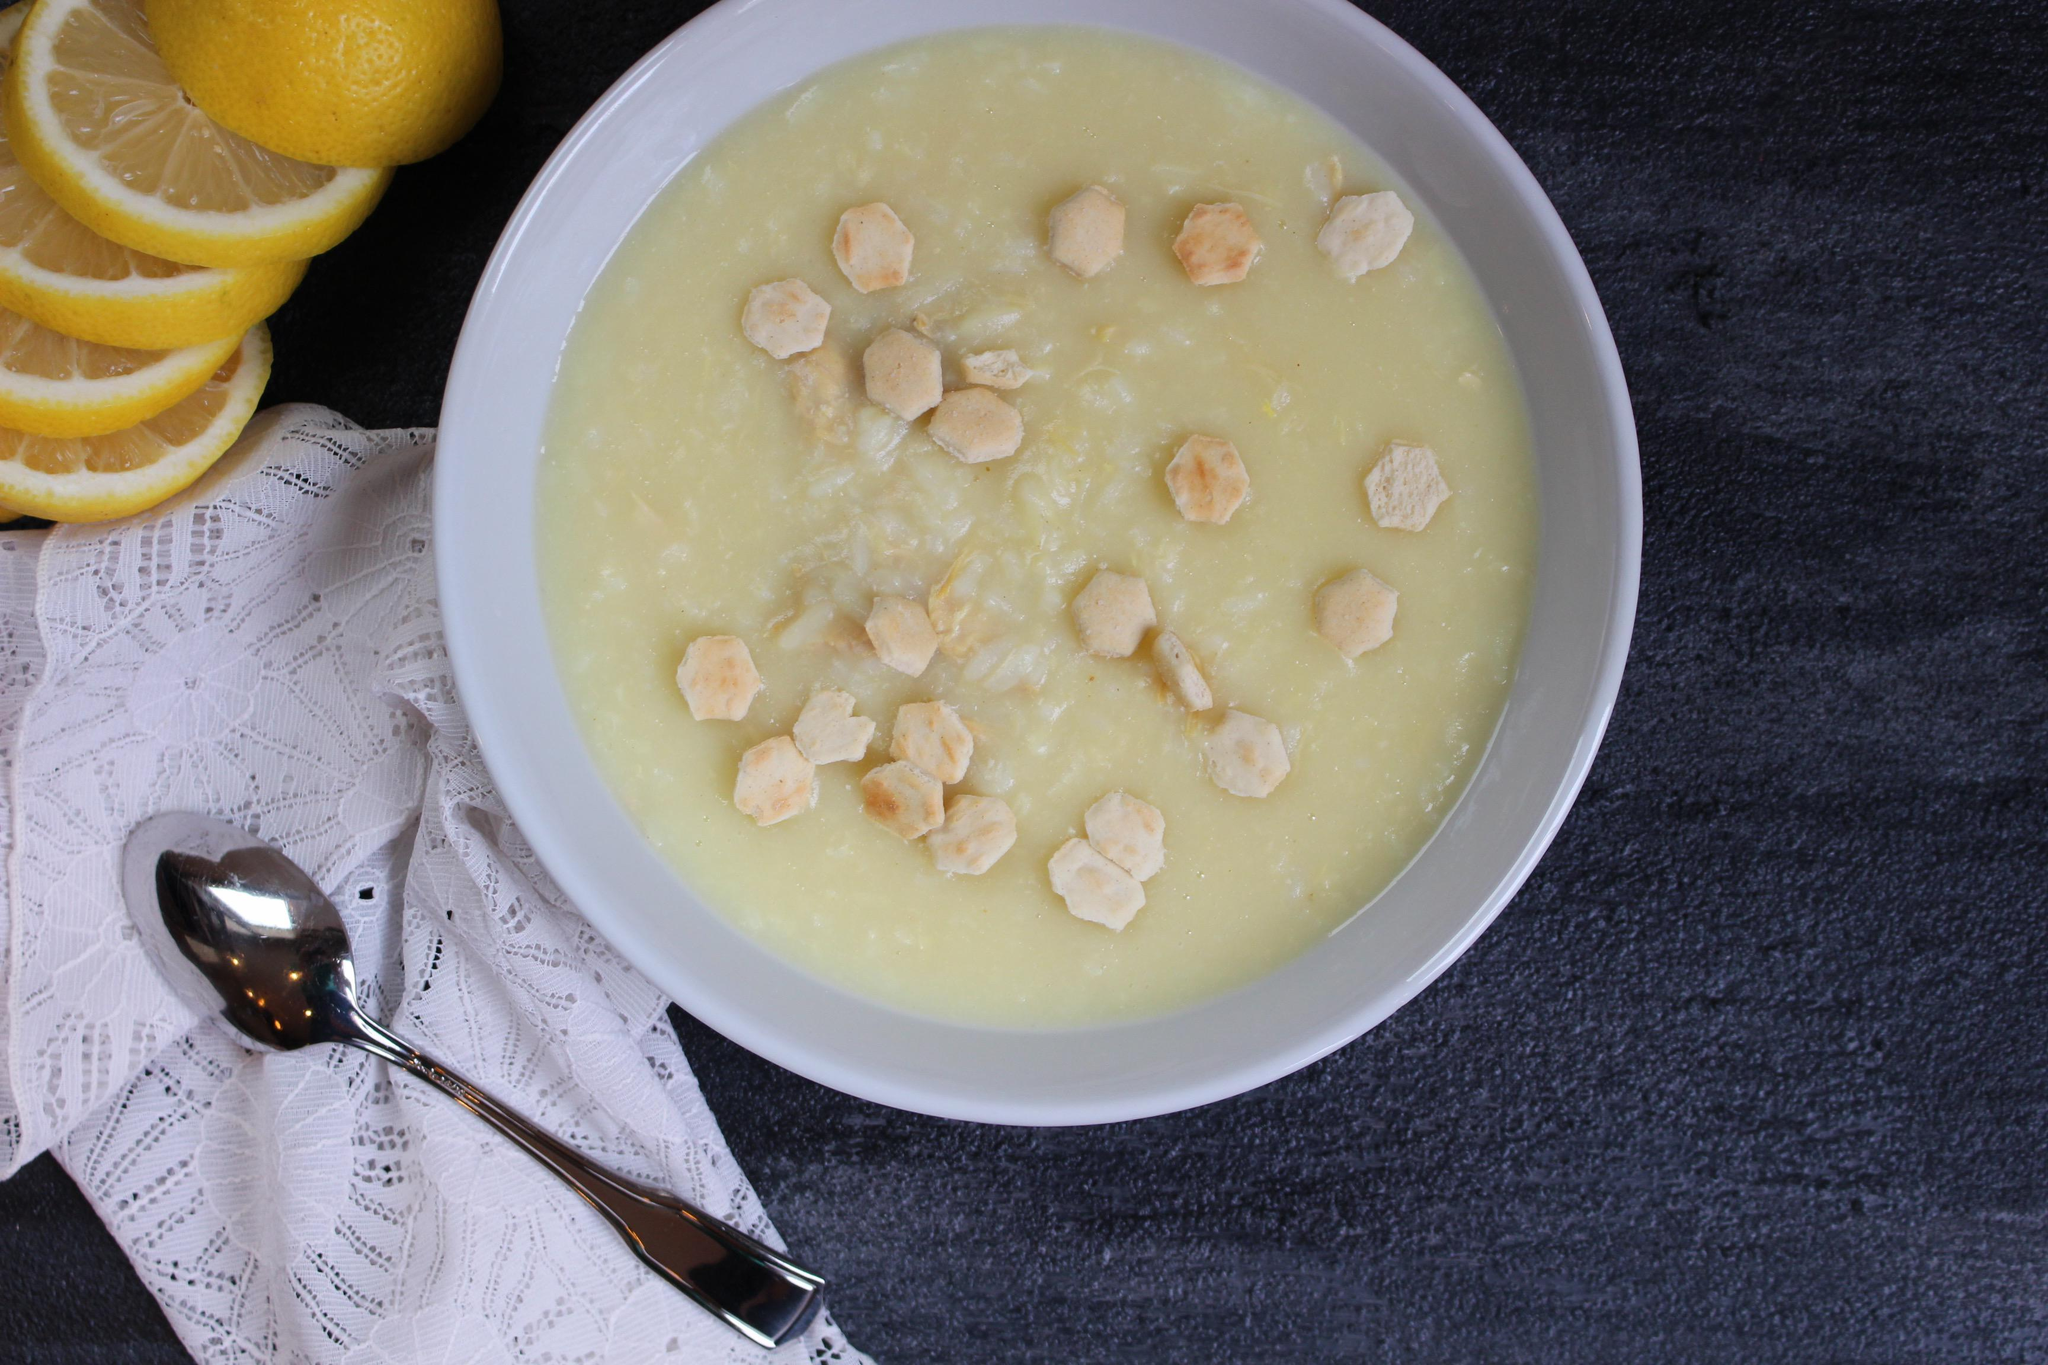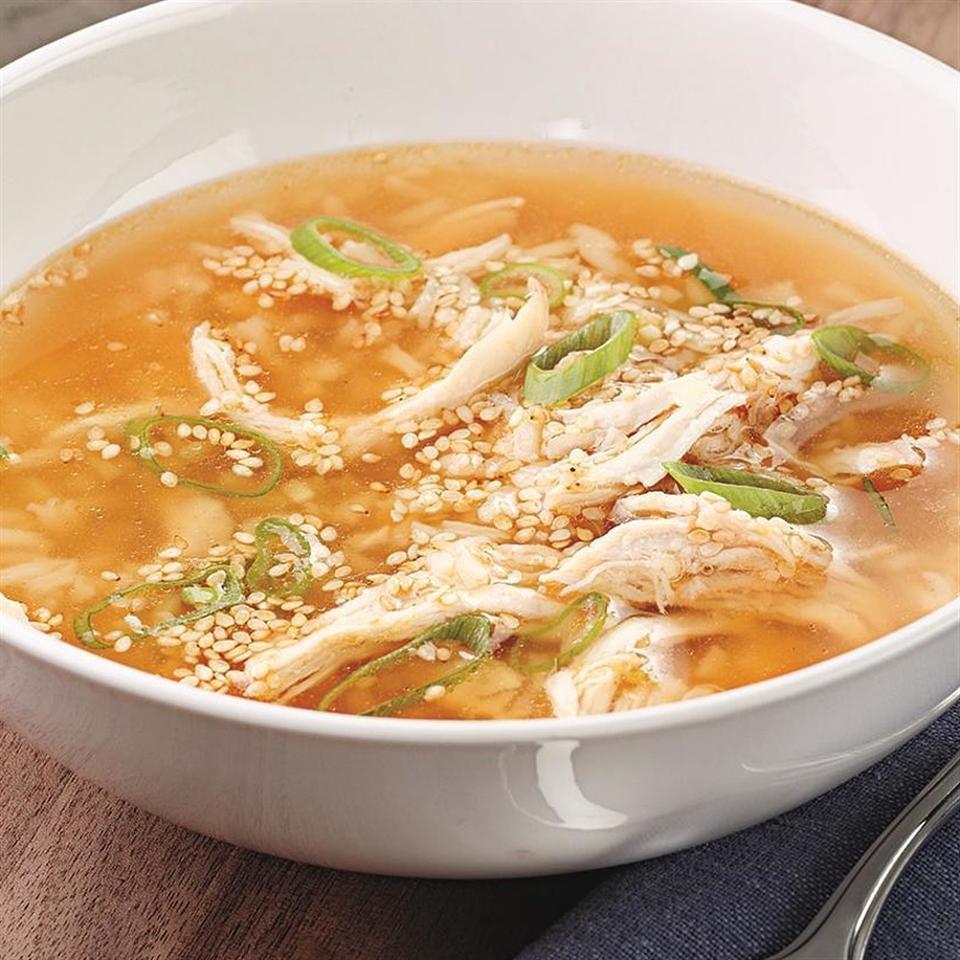The first image is the image on the left, the second image is the image on the right. Evaluate the accuracy of this statement regarding the images: "there is a spoon in the bowl of soup". Is it true? Answer yes or no. No. The first image is the image on the left, the second image is the image on the right. Analyze the images presented: Is the assertion "A spoon is in a white bowl of chicken soup with carrots, while a second image shows two or more bowls of a different chicken soup." valid? Answer yes or no. No. 